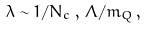Convert formula to latex. <formula><loc_0><loc_0><loc_500><loc_500>\lambda \sim 1 / N _ { c } \, , \, \Lambda / m _ { Q } \, ,</formula> 